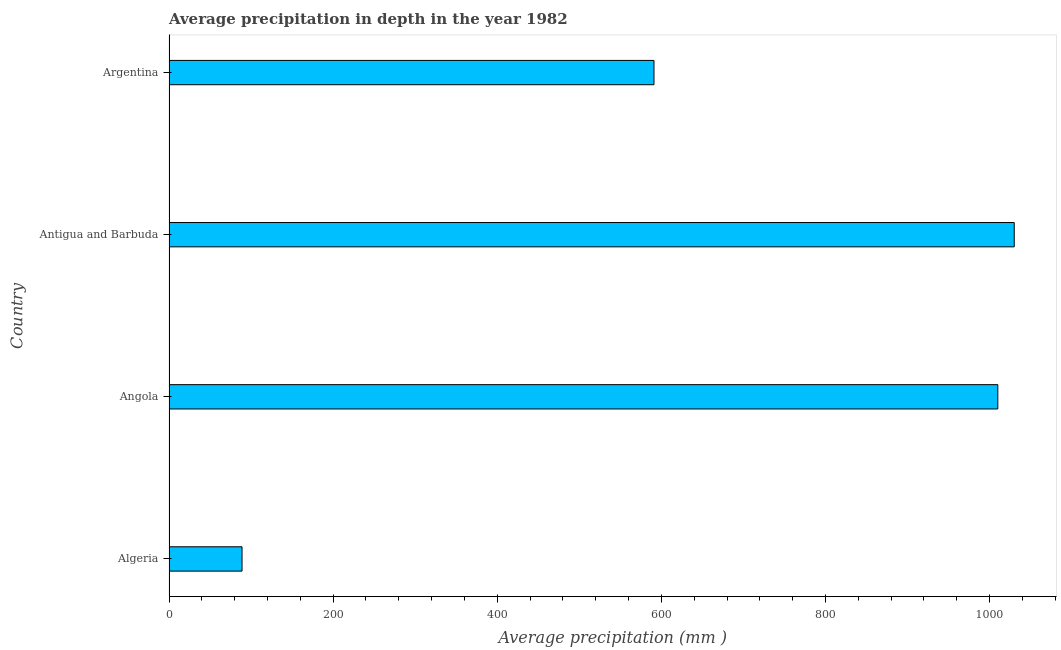Does the graph contain any zero values?
Provide a short and direct response. No. Does the graph contain grids?
Offer a very short reply. No. What is the title of the graph?
Offer a terse response. Average precipitation in depth in the year 1982. What is the label or title of the X-axis?
Your response must be concise. Average precipitation (mm ). What is the label or title of the Y-axis?
Keep it short and to the point. Country. What is the average precipitation in depth in Antigua and Barbuda?
Make the answer very short. 1030. Across all countries, what is the maximum average precipitation in depth?
Keep it short and to the point. 1030. Across all countries, what is the minimum average precipitation in depth?
Offer a very short reply. 89. In which country was the average precipitation in depth maximum?
Keep it short and to the point. Antigua and Barbuda. In which country was the average precipitation in depth minimum?
Your answer should be compact. Algeria. What is the sum of the average precipitation in depth?
Offer a very short reply. 2720. What is the difference between the average precipitation in depth in Algeria and Antigua and Barbuda?
Your answer should be compact. -941. What is the average average precipitation in depth per country?
Your answer should be compact. 680. What is the median average precipitation in depth?
Keep it short and to the point. 800.5. In how many countries, is the average precipitation in depth greater than 600 mm?
Give a very brief answer. 2. What is the ratio of the average precipitation in depth in Angola to that in Argentina?
Provide a short and direct response. 1.71. Is the average precipitation in depth in Algeria less than that in Argentina?
Your response must be concise. Yes. What is the difference between the highest and the lowest average precipitation in depth?
Offer a very short reply. 941. How many countries are there in the graph?
Provide a short and direct response. 4. What is the difference between two consecutive major ticks on the X-axis?
Offer a terse response. 200. Are the values on the major ticks of X-axis written in scientific E-notation?
Offer a very short reply. No. What is the Average precipitation (mm ) of Algeria?
Your answer should be compact. 89. What is the Average precipitation (mm ) of Angola?
Your response must be concise. 1010. What is the Average precipitation (mm ) of Antigua and Barbuda?
Provide a succinct answer. 1030. What is the Average precipitation (mm ) of Argentina?
Your response must be concise. 591. What is the difference between the Average precipitation (mm ) in Algeria and Angola?
Your answer should be very brief. -921. What is the difference between the Average precipitation (mm ) in Algeria and Antigua and Barbuda?
Your response must be concise. -941. What is the difference between the Average precipitation (mm ) in Algeria and Argentina?
Offer a terse response. -502. What is the difference between the Average precipitation (mm ) in Angola and Argentina?
Ensure brevity in your answer.  419. What is the difference between the Average precipitation (mm ) in Antigua and Barbuda and Argentina?
Provide a short and direct response. 439. What is the ratio of the Average precipitation (mm ) in Algeria to that in Angola?
Offer a very short reply. 0.09. What is the ratio of the Average precipitation (mm ) in Algeria to that in Antigua and Barbuda?
Ensure brevity in your answer.  0.09. What is the ratio of the Average precipitation (mm ) in Algeria to that in Argentina?
Offer a terse response. 0.15. What is the ratio of the Average precipitation (mm ) in Angola to that in Antigua and Barbuda?
Keep it short and to the point. 0.98. What is the ratio of the Average precipitation (mm ) in Angola to that in Argentina?
Your answer should be very brief. 1.71. What is the ratio of the Average precipitation (mm ) in Antigua and Barbuda to that in Argentina?
Your answer should be very brief. 1.74. 